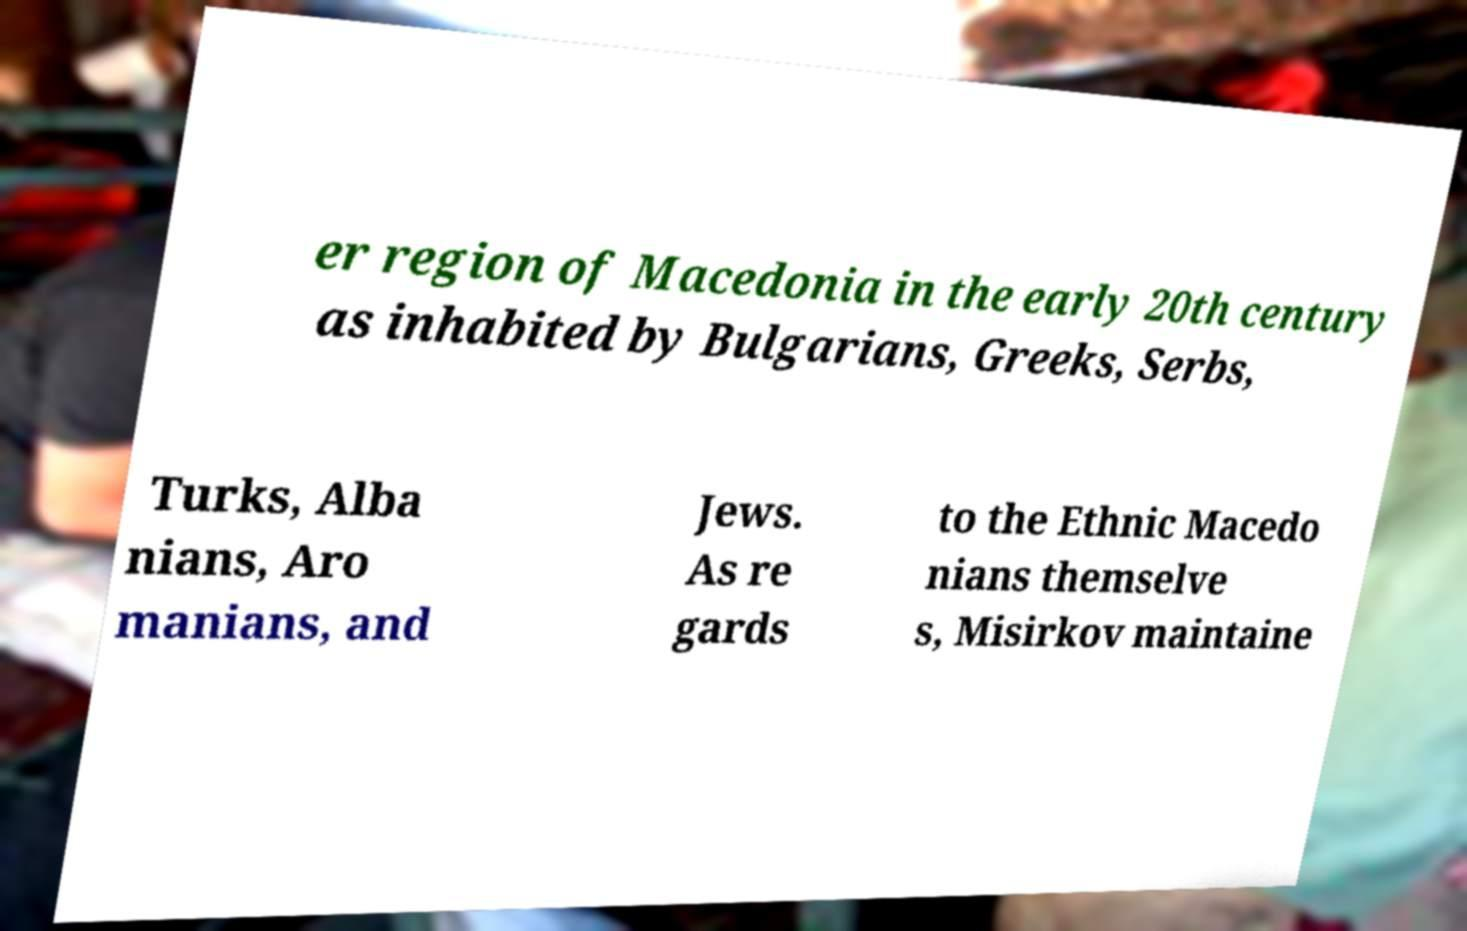Could you extract and type out the text from this image? er region of Macedonia in the early 20th century as inhabited by Bulgarians, Greeks, Serbs, Turks, Alba nians, Aro manians, and Jews. As re gards to the Ethnic Macedo nians themselve s, Misirkov maintaine 